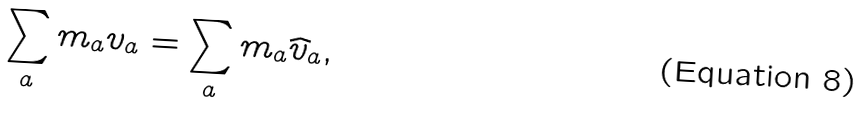Convert formula to latex. <formula><loc_0><loc_0><loc_500><loc_500>\sum _ { a } m _ { a } { v } _ { a } = \sum _ { a } m _ { a } { \widehat { v } } _ { a } ,</formula> 